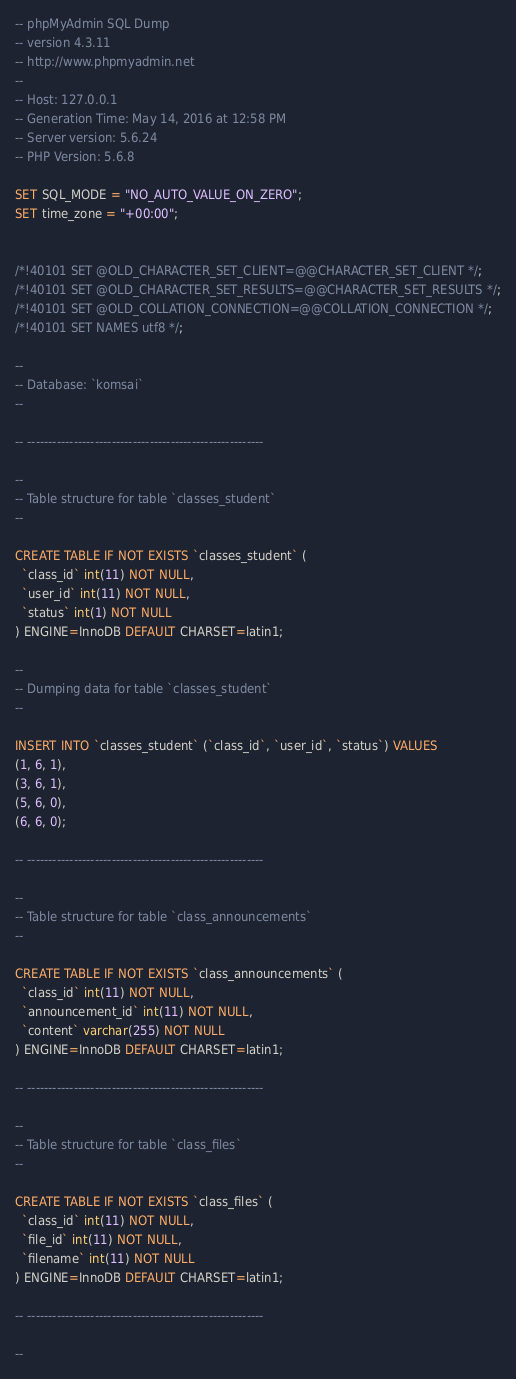<code> <loc_0><loc_0><loc_500><loc_500><_SQL_>-- phpMyAdmin SQL Dump
-- version 4.3.11
-- http://www.phpmyadmin.net
--
-- Host: 127.0.0.1
-- Generation Time: May 14, 2016 at 12:58 PM
-- Server version: 5.6.24
-- PHP Version: 5.6.8

SET SQL_MODE = "NO_AUTO_VALUE_ON_ZERO";
SET time_zone = "+00:00";


/*!40101 SET @OLD_CHARACTER_SET_CLIENT=@@CHARACTER_SET_CLIENT */;
/*!40101 SET @OLD_CHARACTER_SET_RESULTS=@@CHARACTER_SET_RESULTS */;
/*!40101 SET @OLD_COLLATION_CONNECTION=@@COLLATION_CONNECTION */;
/*!40101 SET NAMES utf8 */;

--
-- Database: `komsai`
--

-- --------------------------------------------------------

--
-- Table structure for table `classes_student`
--

CREATE TABLE IF NOT EXISTS `classes_student` (
  `class_id` int(11) NOT NULL,
  `user_id` int(11) NOT NULL,
  `status` int(1) NOT NULL
) ENGINE=InnoDB DEFAULT CHARSET=latin1;

--
-- Dumping data for table `classes_student`
--

INSERT INTO `classes_student` (`class_id`, `user_id`, `status`) VALUES
(1, 6, 1),
(3, 6, 1),
(5, 6, 0),
(6, 6, 0);

-- --------------------------------------------------------

--
-- Table structure for table `class_announcements`
--

CREATE TABLE IF NOT EXISTS `class_announcements` (
  `class_id` int(11) NOT NULL,
  `announcement_id` int(11) NOT NULL,
  `content` varchar(255) NOT NULL
) ENGINE=InnoDB DEFAULT CHARSET=latin1;

-- --------------------------------------------------------

--
-- Table structure for table `class_files`
--

CREATE TABLE IF NOT EXISTS `class_files` (
  `class_id` int(11) NOT NULL,
  `file_id` int(11) NOT NULL,
  `filename` int(11) NOT NULL
) ENGINE=InnoDB DEFAULT CHARSET=latin1;

-- --------------------------------------------------------

--</code> 